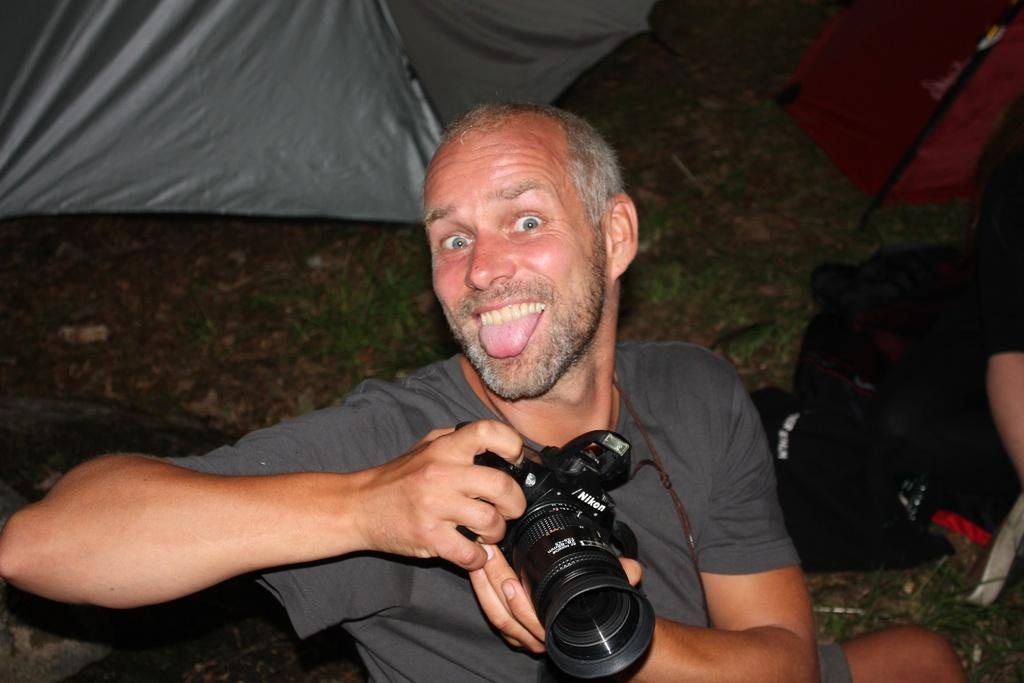What is the main subject of the image? The main subject of the image is a man. What is the man holding in the image? The man is holding a camera. What color is the stranger's head in the image? There is no stranger present in the image, and therefore no head to describe. 